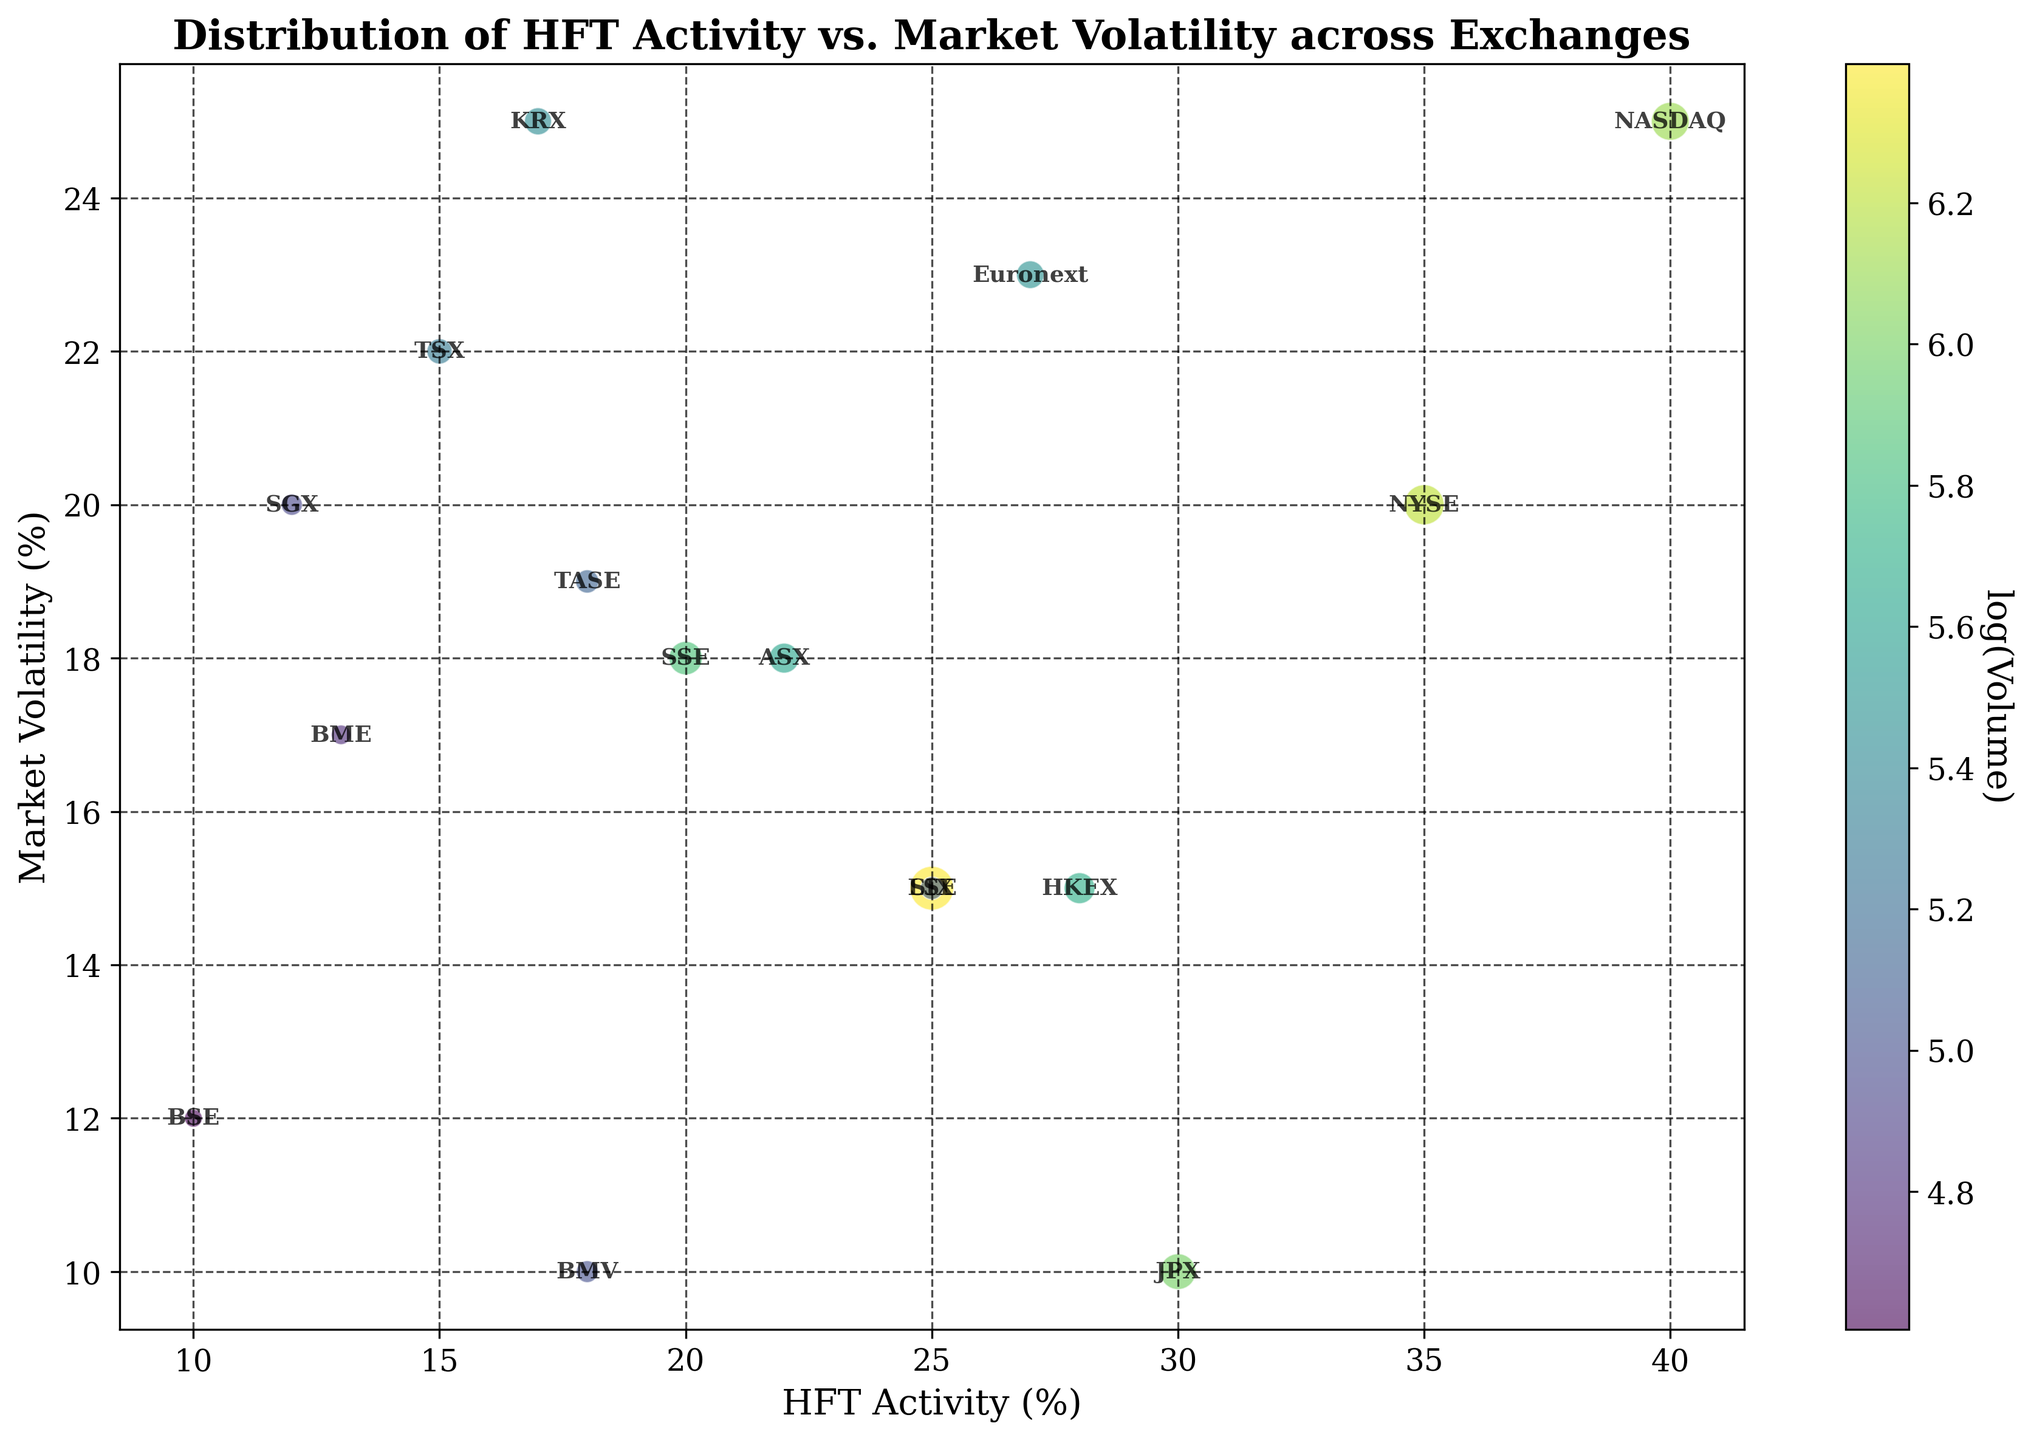Which exchange has the highest HFT activity and what is its market volatility? By looking at the bubble chart, identify the exchange with the maximum HFT activity percentage and then note its corresponding market volatility percentage.
Answer: NASDAQ has 40% HFT activity and 25% market volatility How does the market volatility of NYSE compare to that of TSX? Locate the bubbles for NYSE and TSX. Compare their positions on the y-axis representing market volatility percentage.
Answer: NYSE has 20% volatility, which is less than TSX's 22% What is the relationship between market volatility and volume for the JPX exchange? Find the bubble representing JPX and note its position on the y-axis (market volatility) and its size (volume). Compare these characteristics.
Answer: JPX has 10% volatility and a volume of 400 What is the average HFT activity of NASDAQ, NYSE, and KRX? Sum the HFT activity percentages of NASDAQ (40), NYSE (35), and KRX (17) and then divide by the number of exchanges (3).
Answer: (40 + 35 + 17) / 3 = 30.67% Among the exchanges with market volatility 15%, which has the highest HFT activity and what is its volume? Identify bubbles with 15% market volatility, then compare their HFT activity percentages and note the one with the highest value. Finally, check its corresponding volume.
Answer: LSE has 25% HFT activity and a volume of 600 Which exchange has the smallest volume and what is its market volatility? Find the smallest bubble by size and then note down its corresponding market volatility percentage.
Answer: BSE has the smallest volume (100) and 12% market volatility Does a higher market volatility percentage generally correspond to a larger volume? Look at the bubbles' positions along the y-axis (market volatility) and compare their sizes. Check for any visible trend or pattern.
Answer: Not necessarily, as higher volatility does not consistently align with larger volumes What is the total market volatility percentage for exchanges with HFT activity under 20%? Identify exchanges with HFT activity below 20%. Sum their market volatility percentages: BME (17), TASE (19), SGX (20), BMV (10), TSX (22), BSE (12), and KRX (25).
Answer: 17 + 19 + 20 + 10 + 22 + 12 + 25 = 125% Are there any exchanges with exactly the same market volatility and HFT activity values? If yes, name them and their values. Examine the positions of all bubbles and note if any are perfectly aligned on both axes.
Answer: No, there are no exchanges with exactly the same values for both variables Which exchange shows the least market volatility among exchanges with HFT activity greater than 25%? Filter out exchanges with HFT activity > 25%. From these, find the one with the minimum y-axis value (market volatility).
Answer: JPX has the least market volatility (10%) with HFT activity of 30% 